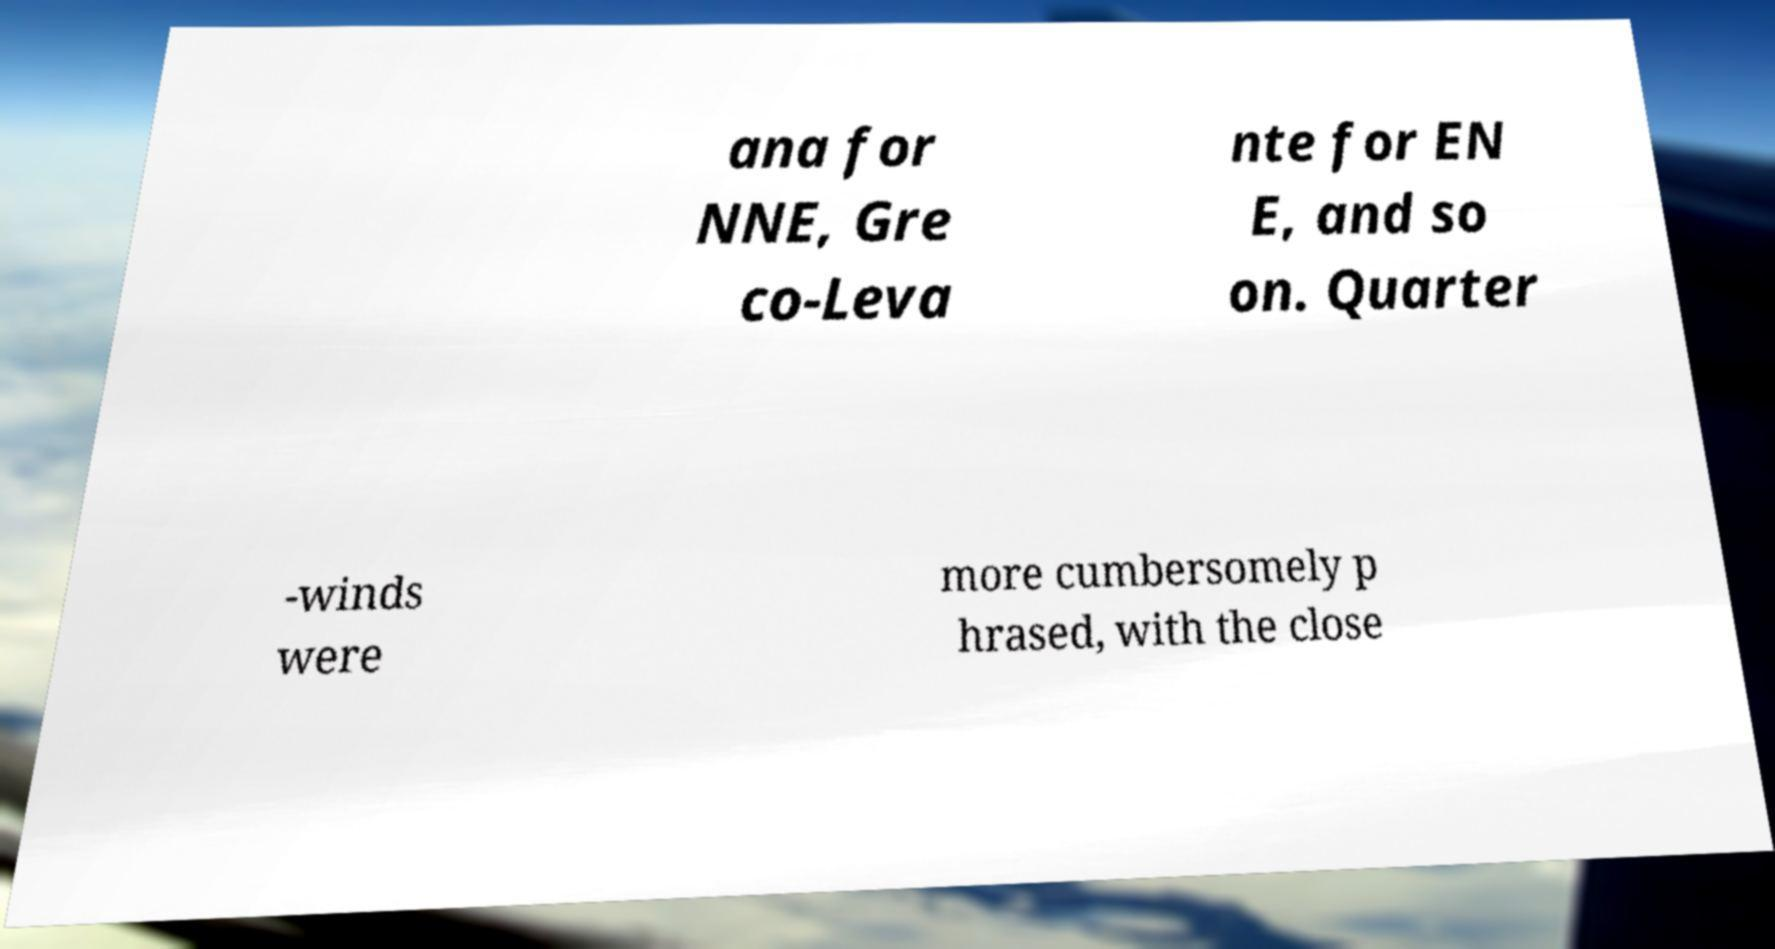Can you accurately transcribe the text from the provided image for me? ana for NNE, Gre co-Leva nte for EN E, and so on. Quarter -winds were more cumbersomely p hrased, with the close 